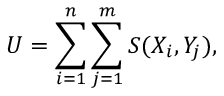<formula> <loc_0><loc_0><loc_500><loc_500>U = \sum _ { i = 1 } ^ { n } \sum _ { j = 1 } ^ { m } S ( X _ { i } , Y _ { j } ) ,</formula> 